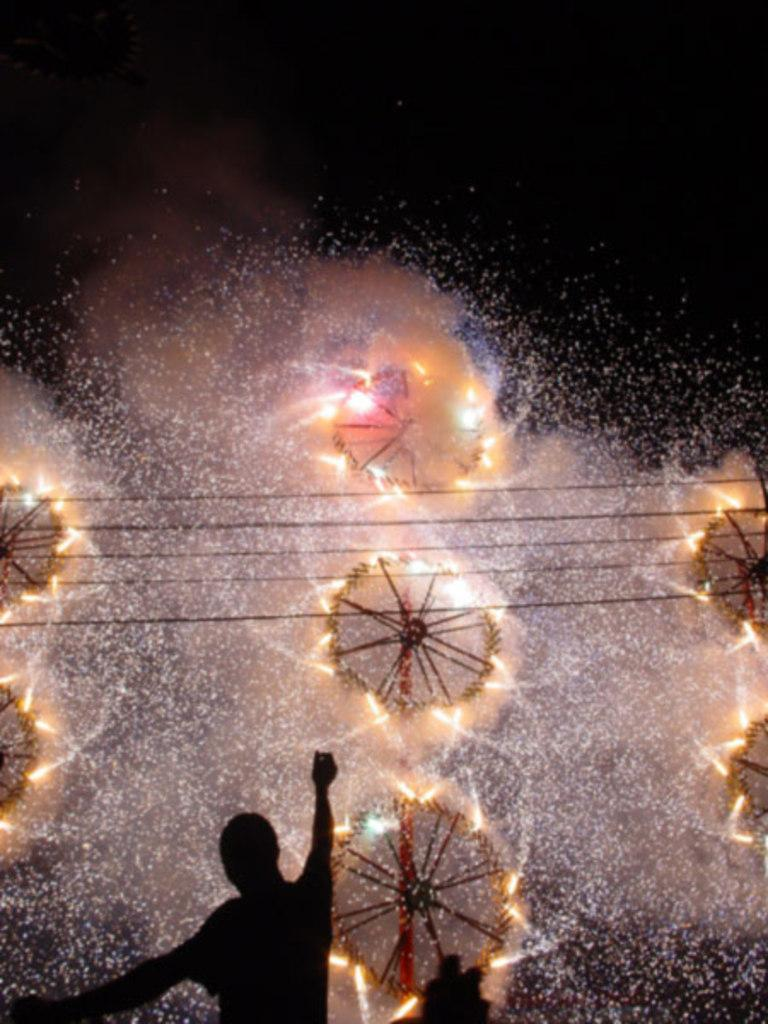What is the main subject of the image? The main subject of the image is fireworks. What can be seen in the image besides the fireworks? There are wires and a person visible in the image. Where is the person located in the image? The person is at the bottom of the image. What is the color of the background in the image? The background is dark. What type of lock can be seen on the truck in the image? There is no truck or lock present in the image; it features fireworks, wires, and a person. How many dimes are visible on the ground in the image? There are no dimes visible on the ground in the image. 